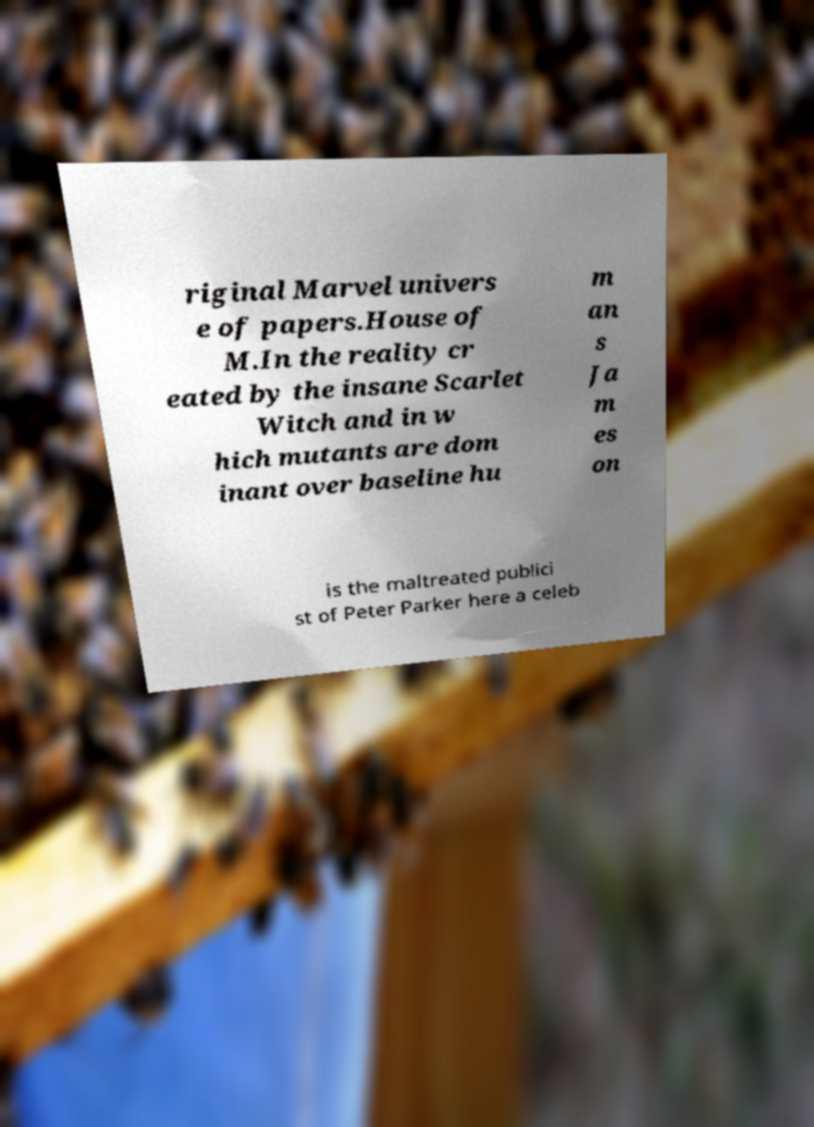What messages or text are displayed in this image? I need them in a readable, typed format. riginal Marvel univers e of papers.House of M.In the reality cr eated by the insane Scarlet Witch and in w hich mutants are dom inant over baseline hu m an s Ja m es on is the maltreated publici st of Peter Parker here a celeb 